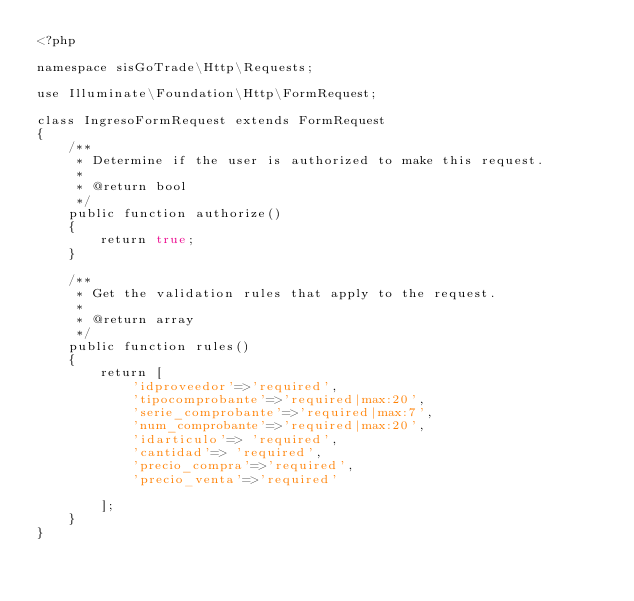Convert code to text. <code><loc_0><loc_0><loc_500><loc_500><_PHP_><?php

namespace sisGoTrade\Http\Requests;

use Illuminate\Foundation\Http\FormRequest;

class IngresoFormRequest extends FormRequest
{
    /**
     * Determine if the user is authorized to make this request.
     *
     * @return bool
     */
    public function authorize()
    {
        return true;
    }

    /**
     * Get the validation rules that apply to the request.
     *
     * @return array
     */
    public function rules()
    {
        return [
            'idproveedor'=>'required',
			'tipocomprobante'=>'required|max:20',
			'serie_comprobante'=>'required|max:7',
			'num_comprobante'=>'required|max:20',
			'idarticulo'=> 'required',
			'cantidad'=> 'required',
			'precio_compra'=>'required',
			'precio_venta'=>'required'
			
        ];
    }
}
</code> 